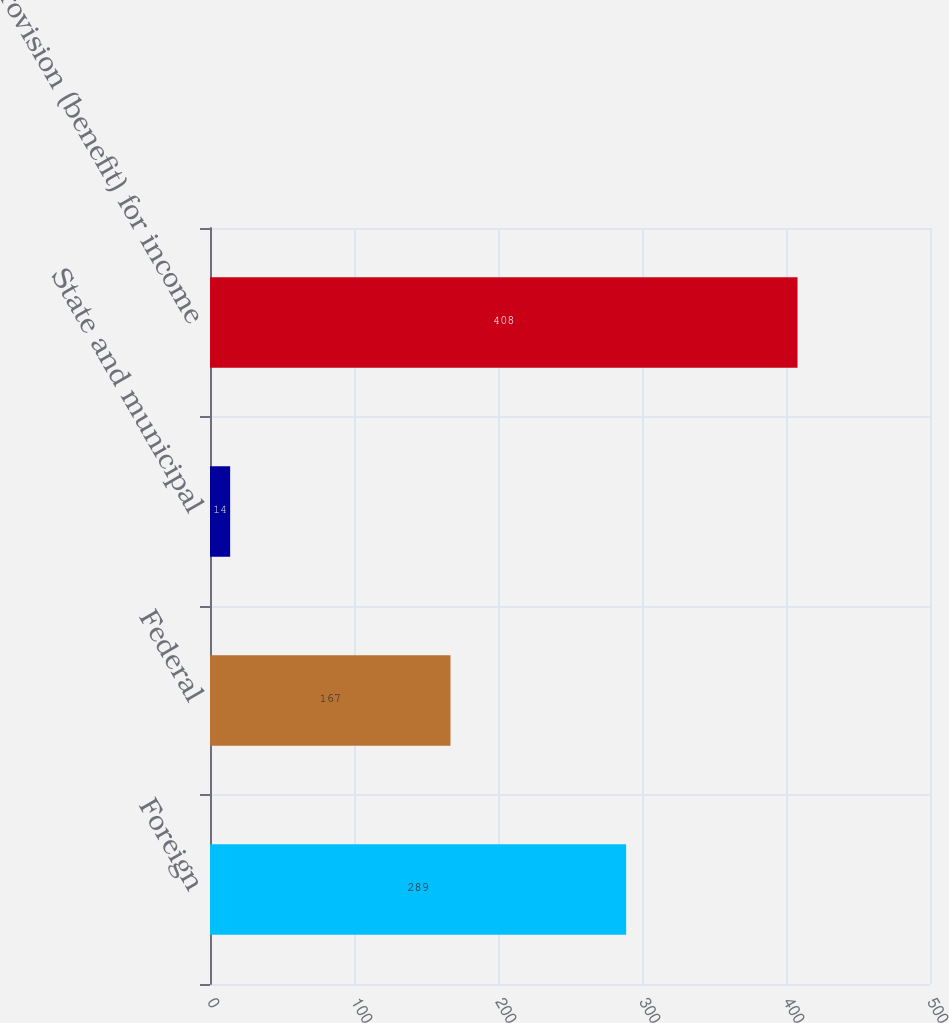Convert chart. <chart><loc_0><loc_0><loc_500><loc_500><bar_chart><fcel>Foreign<fcel>Federal<fcel>State and municipal<fcel>Provision (benefit) for income<nl><fcel>289<fcel>167<fcel>14<fcel>408<nl></chart> 